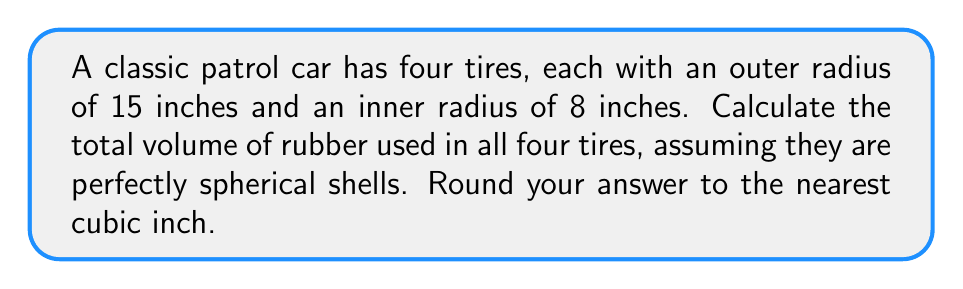Teach me how to tackle this problem. To solve this problem, we'll follow these steps:

1) The volume of a spherical shell is given by the formula:
   $$V = \frac{4}{3}\pi(R^3 - r^3)$$
   where $R$ is the outer radius and $r$ is the inner radius.

2) Let's substitute our values:
   $R = 15$ inches
   $r = 8$ inches

3) Calculate the volume of one tire:
   $$V = \frac{4}{3}\pi(15^3 - 8^3)$$
   $$V = \frac{4}{3}\pi(3375 - 512)$$
   $$V = \frac{4}{3}\pi(2863)$$
   $$V = 3817.3\ldots \text{ cubic inches}$$

4) Since there are four tires, multiply this result by 4:
   $$V_{total} = 4 \times 3817.3\ldots = 15269.3\ldots \text{ cubic inches}$$

5) Rounding to the nearest cubic inch:
   $$V_{total} \approx 15269 \text{ cubic inches}$$
Answer: 15269 cubic inches 